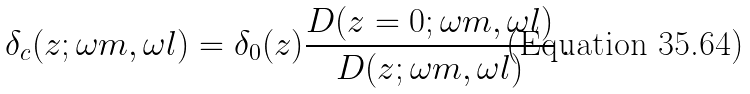<formula> <loc_0><loc_0><loc_500><loc_500>\delta _ { c } ( z ; \omega m , \omega l ) = \delta _ { 0 } ( z ) \frac { D ( z = 0 ; \omega m , \omega l ) } { D ( z ; \omega m , \omega l ) } \, .</formula> 